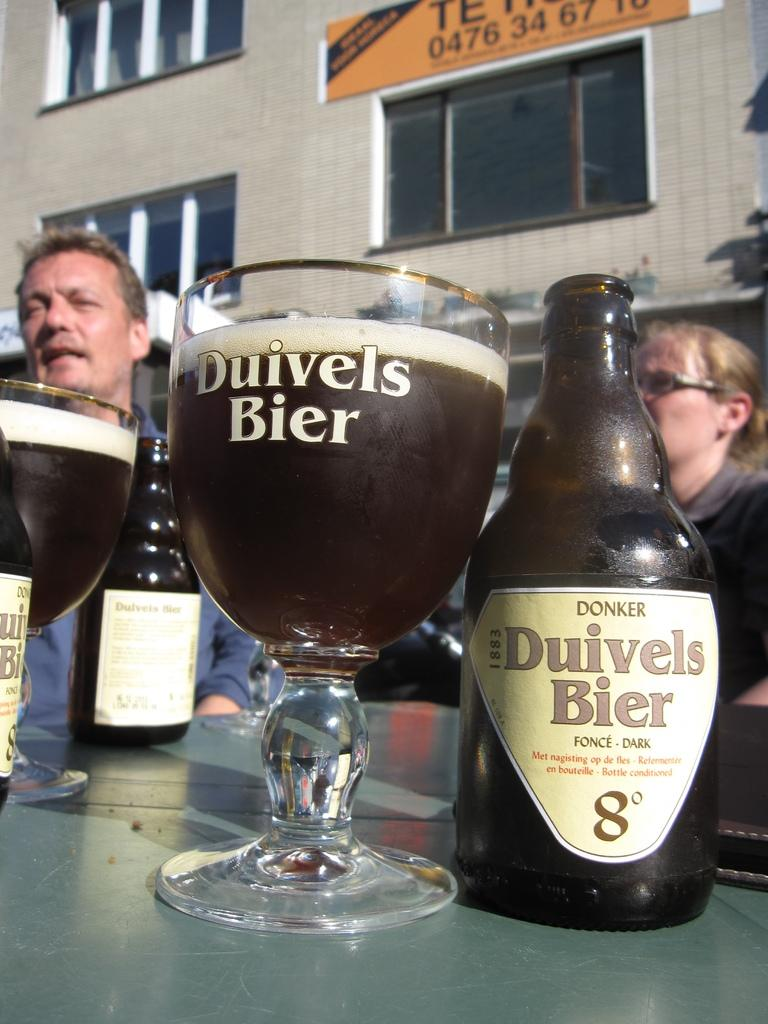<image>
Offer a succinct explanation of the picture presented. A bottle of Duivels Bier sits next to a full class. 